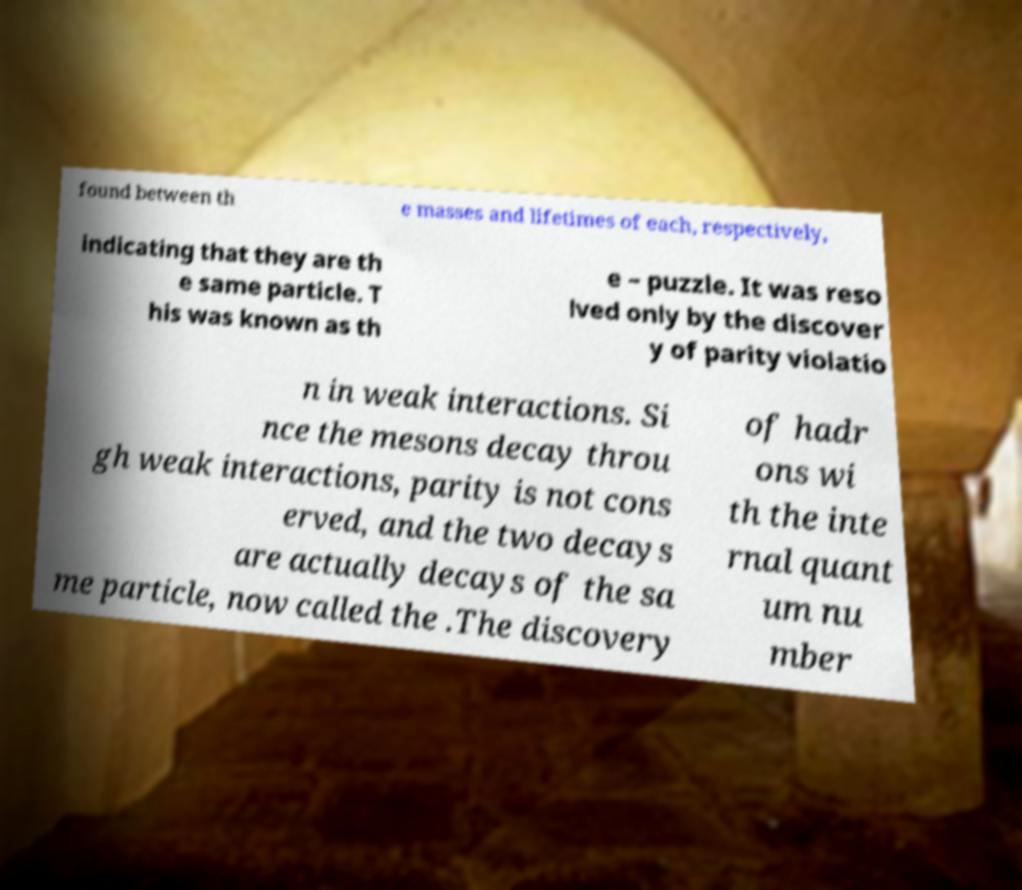Could you assist in decoding the text presented in this image and type it out clearly? found between th e masses and lifetimes of each, respectively, indicating that they are th e same particle. T his was known as th e – puzzle. It was reso lved only by the discover y of parity violatio n in weak interactions. Si nce the mesons decay throu gh weak interactions, parity is not cons erved, and the two decays are actually decays of the sa me particle, now called the .The discovery of hadr ons wi th the inte rnal quant um nu mber 